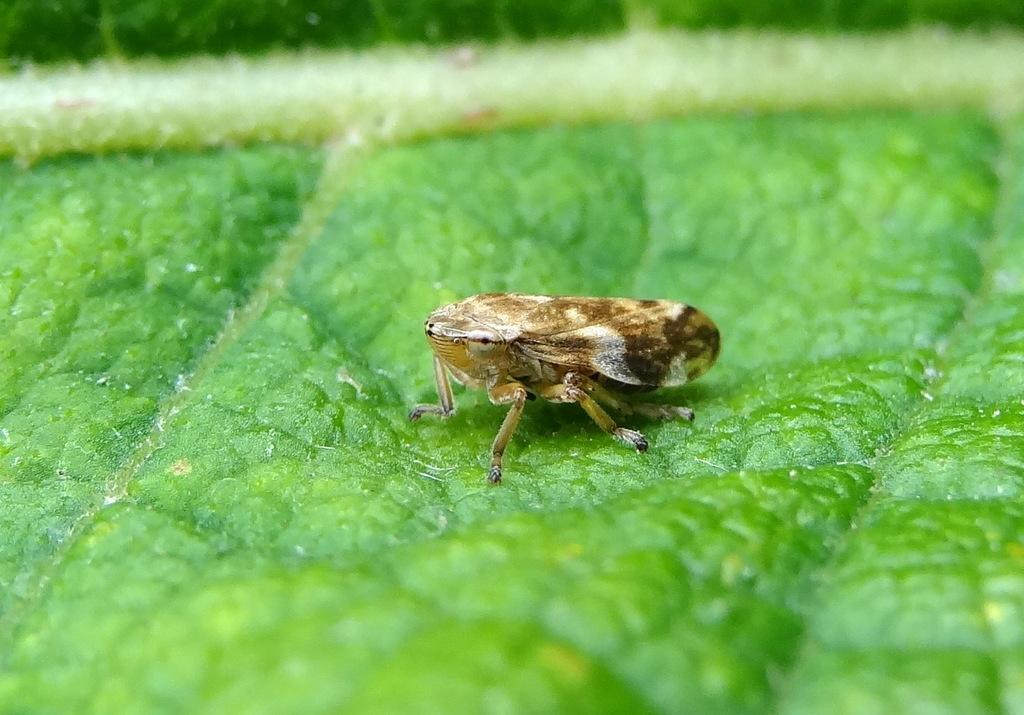What type of creature can be seen in the image? There is an insect in the image. What is the insect resting on or near? The insect is on a green colored object. How many watches can be seen in the image? There are no watches present in the image. What type of trucks are visible in the image? There are no trucks present in the image. 